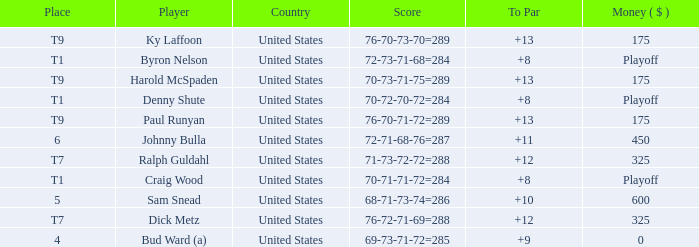What was the country for Sam Snead? United States. 